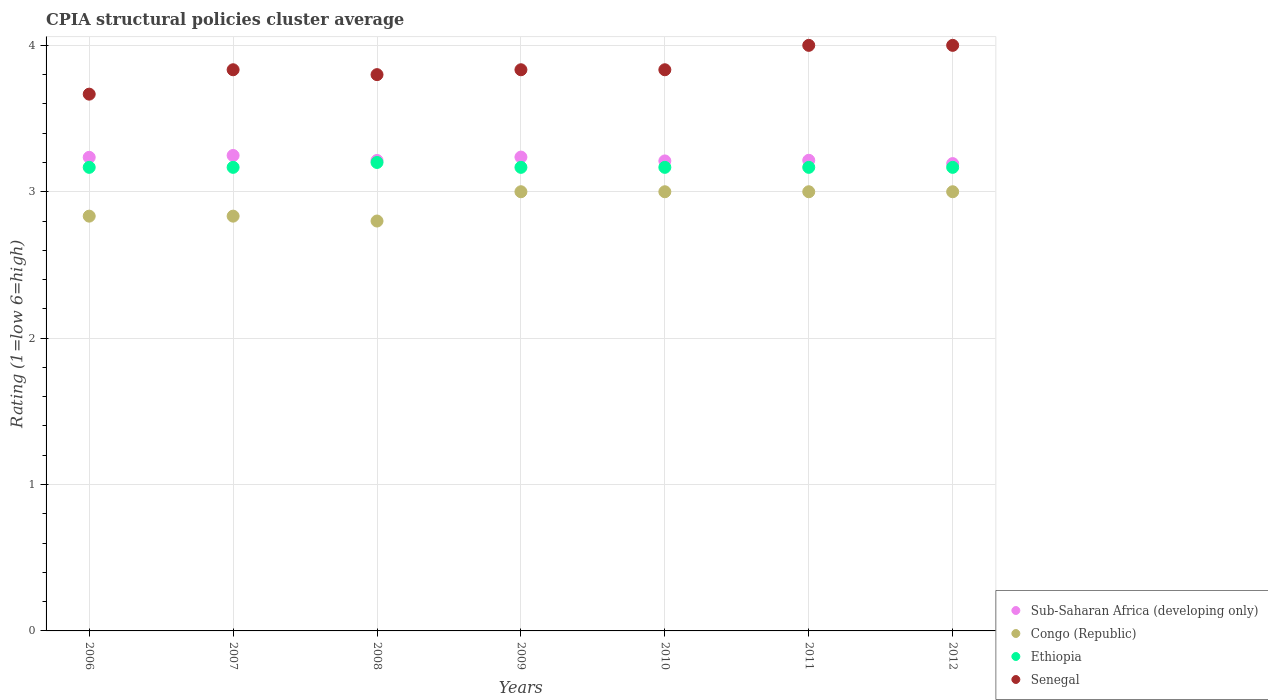Is the number of dotlines equal to the number of legend labels?
Provide a succinct answer. Yes. Across all years, what is the maximum CPIA rating in Ethiopia?
Offer a terse response. 3.2. Across all years, what is the minimum CPIA rating in Congo (Republic)?
Ensure brevity in your answer.  2.8. What is the total CPIA rating in Sub-Saharan Africa (developing only) in the graph?
Your answer should be compact. 22.55. What is the difference between the CPIA rating in Ethiopia in 2008 and that in 2011?
Keep it short and to the point. 0.03. What is the difference between the CPIA rating in Sub-Saharan Africa (developing only) in 2011 and the CPIA rating in Ethiopia in 2007?
Provide a short and direct response. 0.05. What is the average CPIA rating in Senegal per year?
Ensure brevity in your answer.  3.85. In the year 2012, what is the difference between the CPIA rating in Senegal and CPIA rating in Sub-Saharan Africa (developing only)?
Offer a terse response. 0.81. In how many years, is the CPIA rating in Congo (Republic) greater than 2.8?
Give a very brief answer. 6. What is the ratio of the CPIA rating in Ethiopia in 2006 to that in 2008?
Your answer should be compact. 0.99. Is the CPIA rating in Ethiopia in 2007 less than that in 2008?
Make the answer very short. Yes. Is the difference between the CPIA rating in Senegal in 2007 and 2009 greater than the difference between the CPIA rating in Sub-Saharan Africa (developing only) in 2007 and 2009?
Your answer should be compact. No. What is the difference between the highest and the second highest CPIA rating in Senegal?
Your answer should be very brief. 0. What is the difference between the highest and the lowest CPIA rating in Ethiopia?
Your answer should be compact. 0.03. Is the sum of the CPIA rating in Ethiopia in 2006 and 2011 greater than the maximum CPIA rating in Congo (Republic) across all years?
Keep it short and to the point. Yes. Is it the case that in every year, the sum of the CPIA rating in Senegal and CPIA rating in Sub-Saharan Africa (developing only)  is greater than the sum of CPIA rating in Congo (Republic) and CPIA rating in Ethiopia?
Your answer should be very brief. Yes. Is it the case that in every year, the sum of the CPIA rating in Senegal and CPIA rating in Congo (Republic)  is greater than the CPIA rating in Sub-Saharan Africa (developing only)?
Your answer should be very brief. Yes. What is the difference between two consecutive major ticks on the Y-axis?
Your answer should be compact. 1. Are the values on the major ticks of Y-axis written in scientific E-notation?
Provide a short and direct response. No. Does the graph contain any zero values?
Make the answer very short. No. Does the graph contain grids?
Provide a short and direct response. Yes. Where does the legend appear in the graph?
Provide a succinct answer. Bottom right. How are the legend labels stacked?
Your answer should be very brief. Vertical. What is the title of the graph?
Ensure brevity in your answer.  CPIA structural policies cluster average. Does "Algeria" appear as one of the legend labels in the graph?
Your response must be concise. No. What is the Rating (1=low 6=high) of Sub-Saharan Africa (developing only) in 2006?
Offer a terse response. 3.24. What is the Rating (1=low 6=high) of Congo (Republic) in 2006?
Offer a terse response. 2.83. What is the Rating (1=low 6=high) of Ethiopia in 2006?
Make the answer very short. 3.17. What is the Rating (1=low 6=high) in Senegal in 2006?
Ensure brevity in your answer.  3.67. What is the Rating (1=low 6=high) of Sub-Saharan Africa (developing only) in 2007?
Ensure brevity in your answer.  3.25. What is the Rating (1=low 6=high) in Congo (Republic) in 2007?
Provide a short and direct response. 2.83. What is the Rating (1=low 6=high) in Ethiopia in 2007?
Ensure brevity in your answer.  3.17. What is the Rating (1=low 6=high) of Senegal in 2007?
Your answer should be very brief. 3.83. What is the Rating (1=low 6=high) in Sub-Saharan Africa (developing only) in 2008?
Provide a succinct answer. 3.21. What is the Rating (1=low 6=high) of Congo (Republic) in 2008?
Provide a succinct answer. 2.8. What is the Rating (1=low 6=high) of Ethiopia in 2008?
Make the answer very short. 3.2. What is the Rating (1=low 6=high) of Senegal in 2008?
Your response must be concise. 3.8. What is the Rating (1=low 6=high) in Sub-Saharan Africa (developing only) in 2009?
Provide a short and direct response. 3.24. What is the Rating (1=low 6=high) in Ethiopia in 2009?
Give a very brief answer. 3.17. What is the Rating (1=low 6=high) of Senegal in 2009?
Provide a succinct answer. 3.83. What is the Rating (1=low 6=high) in Sub-Saharan Africa (developing only) in 2010?
Provide a short and direct response. 3.21. What is the Rating (1=low 6=high) of Ethiopia in 2010?
Your answer should be very brief. 3.17. What is the Rating (1=low 6=high) of Senegal in 2010?
Your answer should be compact. 3.83. What is the Rating (1=low 6=high) in Sub-Saharan Africa (developing only) in 2011?
Your response must be concise. 3.21. What is the Rating (1=low 6=high) in Congo (Republic) in 2011?
Your response must be concise. 3. What is the Rating (1=low 6=high) of Ethiopia in 2011?
Your response must be concise. 3.17. What is the Rating (1=low 6=high) of Sub-Saharan Africa (developing only) in 2012?
Keep it short and to the point. 3.19. What is the Rating (1=low 6=high) of Ethiopia in 2012?
Offer a terse response. 3.17. Across all years, what is the maximum Rating (1=low 6=high) of Sub-Saharan Africa (developing only)?
Your answer should be very brief. 3.25. Across all years, what is the maximum Rating (1=low 6=high) of Ethiopia?
Give a very brief answer. 3.2. Across all years, what is the maximum Rating (1=low 6=high) in Senegal?
Ensure brevity in your answer.  4. Across all years, what is the minimum Rating (1=low 6=high) of Sub-Saharan Africa (developing only)?
Offer a terse response. 3.19. Across all years, what is the minimum Rating (1=low 6=high) in Ethiopia?
Provide a succinct answer. 3.17. Across all years, what is the minimum Rating (1=low 6=high) of Senegal?
Provide a succinct answer. 3.67. What is the total Rating (1=low 6=high) in Sub-Saharan Africa (developing only) in the graph?
Offer a terse response. 22.55. What is the total Rating (1=low 6=high) of Congo (Republic) in the graph?
Your response must be concise. 20.47. What is the total Rating (1=low 6=high) in Senegal in the graph?
Offer a very short reply. 26.97. What is the difference between the Rating (1=low 6=high) of Sub-Saharan Africa (developing only) in 2006 and that in 2007?
Keep it short and to the point. -0.01. What is the difference between the Rating (1=low 6=high) of Congo (Republic) in 2006 and that in 2007?
Provide a short and direct response. 0. What is the difference between the Rating (1=low 6=high) of Ethiopia in 2006 and that in 2007?
Your response must be concise. 0. What is the difference between the Rating (1=low 6=high) of Senegal in 2006 and that in 2007?
Ensure brevity in your answer.  -0.17. What is the difference between the Rating (1=low 6=high) of Sub-Saharan Africa (developing only) in 2006 and that in 2008?
Provide a succinct answer. 0.02. What is the difference between the Rating (1=low 6=high) in Ethiopia in 2006 and that in 2008?
Your answer should be very brief. -0.03. What is the difference between the Rating (1=low 6=high) in Senegal in 2006 and that in 2008?
Your answer should be very brief. -0.13. What is the difference between the Rating (1=low 6=high) of Sub-Saharan Africa (developing only) in 2006 and that in 2009?
Provide a succinct answer. -0. What is the difference between the Rating (1=low 6=high) in Congo (Republic) in 2006 and that in 2009?
Provide a succinct answer. -0.17. What is the difference between the Rating (1=low 6=high) in Sub-Saharan Africa (developing only) in 2006 and that in 2010?
Your response must be concise. 0.02. What is the difference between the Rating (1=low 6=high) of Ethiopia in 2006 and that in 2010?
Your answer should be very brief. 0. What is the difference between the Rating (1=low 6=high) of Senegal in 2006 and that in 2010?
Your answer should be very brief. -0.17. What is the difference between the Rating (1=low 6=high) in Sub-Saharan Africa (developing only) in 2006 and that in 2011?
Provide a succinct answer. 0.02. What is the difference between the Rating (1=low 6=high) of Ethiopia in 2006 and that in 2011?
Make the answer very short. 0. What is the difference between the Rating (1=low 6=high) of Sub-Saharan Africa (developing only) in 2006 and that in 2012?
Your answer should be very brief. 0.04. What is the difference between the Rating (1=low 6=high) in Ethiopia in 2006 and that in 2012?
Give a very brief answer. 0. What is the difference between the Rating (1=low 6=high) in Senegal in 2006 and that in 2012?
Offer a terse response. -0.33. What is the difference between the Rating (1=low 6=high) in Sub-Saharan Africa (developing only) in 2007 and that in 2008?
Keep it short and to the point. 0.03. What is the difference between the Rating (1=low 6=high) in Ethiopia in 2007 and that in 2008?
Keep it short and to the point. -0.03. What is the difference between the Rating (1=low 6=high) in Sub-Saharan Africa (developing only) in 2007 and that in 2009?
Provide a short and direct response. 0.01. What is the difference between the Rating (1=low 6=high) in Congo (Republic) in 2007 and that in 2009?
Give a very brief answer. -0.17. What is the difference between the Rating (1=low 6=high) of Sub-Saharan Africa (developing only) in 2007 and that in 2010?
Provide a short and direct response. 0.04. What is the difference between the Rating (1=low 6=high) in Congo (Republic) in 2007 and that in 2010?
Keep it short and to the point. -0.17. What is the difference between the Rating (1=low 6=high) in Sub-Saharan Africa (developing only) in 2007 and that in 2011?
Your answer should be very brief. 0.03. What is the difference between the Rating (1=low 6=high) in Ethiopia in 2007 and that in 2011?
Your response must be concise. 0. What is the difference between the Rating (1=low 6=high) in Senegal in 2007 and that in 2011?
Your response must be concise. -0.17. What is the difference between the Rating (1=low 6=high) of Sub-Saharan Africa (developing only) in 2007 and that in 2012?
Your answer should be compact. 0.06. What is the difference between the Rating (1=low 6=high) in Ethiopia in 2007 and that in 2012?
Your answer should be compact. 0. What is the difference between the Rating (1=low 6=high) in Sub-Saharan Africa (developing only) in 2008 and that in 2009?
Offer a terse response. -0.02. What is the difference between the Rating (1=low 6=high) in Congo (Republic) in 2008 and that in 2009?
Make the answer very short. -0.2. What is the difference between the Rating (1=low 6=high) of Senegal in 2008 and that in 2009?
Provide a succinct answer. -0.03. What is the difference between the Rating (1=low 6=high) of Sub-Saharan Africa (developing only) in 2008 and that in 2010?
Offer a terse response. 0. What is the difference between the Rating (1=low 6=high) of Ethiopia in 2008 and that in 2010?
Your response must be concise. 0.03. What is the difference between the Rating (1=low 6=high) in Senegal in 2008 and that in 2010?
Offer a terse response. -0.03. What is the difference between the Rating (1=low 6=high) in Sub-Saharan Africa (developing only) in 2008 and that in 2011?
Offer a terse response. -0. What is the difference between the Rating (1=low 6=high) of Congo (Republic) in 2008 and that in 2011?
Provide a succinct answer. -0.2. What is the difference between the Rating (1=low 6=high) in Ethiopia in 2008 and that in 2011?
Keep it short and to the point. 0.03. What is the difference between the Rating (1=low 6=high) in Sub-Saharan Africa (developing only) in 2008 and that in 2012?
Ensure brevity in your answer.  0.02. What is the difference between the Rating (1=low 6=high) of Sub-Saharan Africa (developing only) in 2009 and that in 2010?
Offer a terse response. 0.03. What is the difference between the Rating (1=low 6=high) of Ethiopia in 2009 and that in 2010?
Your answer should be compact. 0. What is the difference between the Rating (1=low 6=high) of Sub-Saharan Africa (developing only) in 2009 and that in 2011?
Make the answer very short. 0.02. What is the difference between the Rating (1=low 6=high) in Ethiopia in 2009 and that in 2011?
Your response must be concise. 0. What is the difference between the Rating (1=low 6=high) in Sub-Saharan Africa (developing only) in 2009 and that in 2012?
Offer a very short reply. 0.04. What is the difference between the Rating (1=low 6=high) of Congo (Republic) in 2009 and that in 2012?
Give a very brief answer. 0. What is the difference between the Rating (1=low 6=high) in Senegal in 2009 and that in 2012?
Provide a short and direct response. -0.17. What is the difference between the Rating (1=low 6=high) of Sub-Saharan Africa (developing only) in 2010 and that in 2011?
Ensure brevity in your answer.  -0. What is the difference between the Rating (1=low 6=high) of Ethiopia in 2010 and that in 2011?
Provide a succinct answer. 0. What is the difference between the Rating (1=low 6=high) of Sub-Saharan Africa (developing only) in 2010 and that in 2012?
Your answer should be compact. 0.02. What is the difference between the Rating (1=low 6=high) in Ethiopia in 2010 and that in 2012?
Offer a terse response. 0. What is the difference between the Rating (1=low 6=high) in Senegal in 2010 and that in 2012?
Offer a very short reply. -0.17. What is the difference between the Rating (1=low 6=high) in Sub-Saharan Africa (developing only) in 2011 and that in 2012?
Offer a very short reply. 0.02. What is the difference between the Rating (1=low 6=high) of Congo (Republic) in 2011 and that in 2012?
Your answer should be compact. 0. What is the difference between the Rating (1=low 6=high) of Ethiopia in 2011 and that in 2012?
Give a very brief answer. 0. What is the difference between the Rating (1=low 6=high) in Senegal in 2011 and that in 2012?
Give a very brief answer. 0. What is the difference between the Rating (1=low 6=high) in Sub-Saharan Africa (developing only) in 2006 and the Rating (1=low 6=high) in Congo (Republic) in 2007?
Give a very brief answer. 0.4. What is the difference between the Rating (1=low 6=high) of Sub-Saharan Africa (developing only) in 2006 and the Rating (1=low 6=high) of Ethiopia in 2007?
Your response must be concise. 0.07. What is the difference between the Rating (1=low 6=high) of Sub-Saharan Africa (developing only) in 2006 and the Rating (1=low 6=high) of Senegal in 2007?
Give a very brief answer. -0.6. What is the difference between the Rating (1=low 6=high) in Sub-Saharan Africa (developing only) in 2006 and the Rating (1=low 6=high) in Congo (Republic) in 2008?
Keep it short and to the point. 0.44. What is the difference between the Rating (1=low 6=high) of Sub-Saharan Africa (developing only) in 2006 and the Rating (1=low 6=high) of Ethiopia in 2008?
Your answer should be very brief. 0.04. What is the difference between the Rating (1=low 6=high) in Sub-Saharan Africa (developing only) in 2006 and the Rating (1=low 6=high) in Senegal in 2008?
Offer a terse response. -0.56. What is the difference between the Rating (1=low 6=high) of Congo (Republic) in 2006 and the Rating (1=low 6=high) of Ethiopia in 2008?
Keep it short and to the point. -0.37. What is the difference between the Rating (1=low 6=high) of Congo (Republic) in 2006 and the Rating (1=low 6=high) of Senegal in 2008?
Keep it short and to the point. -0.97. What is the difference between the Rating (1=low 6=high) in Ethiopia in 2006 and the Rating (1=low 6=high) in Senegal in 2008?
Your response must be concise. -0.63. What is the difference between the Rating (1=low 6=high) in Sub-Saharan Africa (developing only) in 2006 and the Rating (1=low 6=high) in Congo (Republic) in 2009?
Your answer should be very brief. 0.24. What is the difference between the Rating (1=low 6=high) in Sub-Saharan Africa (developing only) in 2006 and the Rating (1=low 6=high) in Ethiopia in 2009?
Give a very brief answer. 0.07. What is the difference between the Rating (1=low 6=high) in Sub-Saharan Africa (developing only) in 2006 and the Rating (1=low 6=high) in Senegal in 2009?
Provide a succinct answer. -0.6. What is the difference between the Rating (1=low 6=high) of Congo (Republic) in 2006 and the Rating (1=low 6=high) of Ethiopia in 2009?
Keep it short and to the point. -0.33. What is the difference between the Rating (1=low 6=high) in Sub-Saharan Africa (developing only) in 2006 and the Rating (1=low 6=high) in Congo (Republic) in 2010?
Keep it short and to the point. 0.24. What is the difference between the Rating (1=low 6=high) in Sub-Saharan Africa (developing only) in 2006 and the Rating (1=low 6=high) in Ethiopia in 2010?
Give a very brief answer. 0.07. What is the difference between the Rating (1=low 6=high) in Sub-Saharan Africa (developing only) in 2006 and the Rating (1=low 6=high) in Senegal in 2010?
Your answer should be very brief. -0.6. What is the difference between the Rating (1=low 6=high) of Congo (Republic) in 2006 and the Rating (1=low 6=high) of Ethiopia in 2010?
Your answer should be very brief. -0.33. What is the difference between the Rating (1=low 6=high) of Congo (Republic) in 2006 and the Rating (1=low 6=high) of Senegal in 2010?
Your answer should be compact. -1. What is the difference between the Rating (1=low 6=high) of Ethiopia in 2006 and the Rating (1=low 6=high) of Senegal in 2010?
Give a very brief answer. -0.67. What is the difference between the Rating (1=low 6=high) in Sub-Saharan Africa (developing only) in 2006 and the Rating (1=low 6=high) in Congo (Republic) in 2011?
Provide a short and direct response. 0.24. What is the difference between the Rating (1=low 6=high) in Sub-Saharan Africa (developing only) in 2006 and the Rating (1=low 6=high) in Ethiopia in 2011?
Offer a terse response. 0.07. What is the difference between the Rating (1=low 6=high) in Sub-Saharan Africa (developing only) in 2006 and the Rating (1=low 6=high) in Senegal in 2011?
Your answer should be compact. -0.76. What is the difference between the Rating (1=low 6=high) of Congo (Republic) in 2006 and the Rating (1=low 6=high) of Senegal in 2011?
Provide a succinct answer. -1.17. What is the difference between the Rating (1=low 6=high) in Ethiopia in 2006 and the Rating (1=low 6=high) in Senegal in 2011?
Your answer should be very brief. -0.83. What is the difference between the Rating (1=low 6=high) in Sub-Saharan Africa (developing only) in 2006 and the Rating (1=low 6=high) in Congo (Republic) in 2012?
Your answer should be compact. 0.24. What is the difference between the Rating (1=low 6=high) in Sub-Saharan Africa (developing only) in 2006 and the Rating (1=low 6=high) in Ethiopia in 2012?
Give a very brief answer. 0.07. What is the difference between the Rating (1=low 6=high) in Sub-Saharan Africa (developing only) in 2006 and the Rating (1=low 6=high) in Senegal in 2012?
Your response must be concise. -0.76. What is the difference between the Rating (1=low 6=high) in Congo (Republic) in 2006 and the Rating (1=low 6=high) in Senegal in 2012?
Your response must be concise. -1.17. What is the difference between the Rating (1=low 6=high) in Sub-Saharan Africa (developing only) in 2007 and the Rating (1=low 6=high) in Congo (Republic) in 2008?
Your answer should be compact. 0.45. What is the difference between the Rating (1=low 6=high) of Sub-Saharan Africa (developing only) in 2007 and the Rating (1=low 6=high) of Ethiopia in 2008?
Offer a very short reply. 0.05. What is the difference between the Rating (1=low 6=high) of Sub-Saharan Africa (developing only) in 2007 and the Rating (1=low 6=high) of Senegal in 2008?
Provide a short and direct response. -0.55. What is the difference between the Rating (1=low 6=high) in Congo (Republic) in 2007 and the Rating (1=low 6=high) in Ethiopia in 2008?
Your answer should be compact. -0.37. What is the difference between the Rating (1=low 6=high) in Congo (Republic) in 2007 and the Rating (1=low 6=high) in Senegal in 2008?
Make the answer very short. -0.97. What is the difference between the Rating (1=low 6=high) in Ethiopia in 2007 and the Rating (1=low 6=high) in Senegal in 2008?
Offer a terse response. -0.63. What is the difference between the Rating (1=low 6=high) in Sub-Saharan Africa (developing only) in 2007 and the Rating (1=low 6=high) in Congo (Republic) in 2009?
Provide a short and direct response. 0.25. What is the difference between the Rating (1=low 6=high) in Sub-Saharan Africa (developing only) in 2007 and the Rating (1=low 6=high) in Ethiopia in 2009?
Your response must be concise. 0.08. What is the difference between the Rating (1=low 6=high) in Sub-Saharan Africa (developing only) in 2007 and the Rating (1=low 6=high) in Senegal in 2009?
Your answer should be compact. -0.59. What is the difference between the Rating (1=low 6=high) in Congo (Republic) in 2007 and the Rating (1=low 6=high) in Senegal in 2009?
Your answer should be compact. -1. What is the difference between the Rating (1=low 6=high) of Ethiopia in 2007 and the Rating (1=low 6=high) of Senegal in 2009?
Ensure brevity in your answer.  -0.67. What is the difference between the Rating (1=low 6=high) in Sub-Saharan Africa (developing only) in 2007 and the Rating (1=low 6=high) in Congo (Republic) in 2010?
Give a very brief answer. 0.25. What is the difference between the Rating (1=low 6=high) of Sub-Saharan Africa (developing only) in 2007 and the Rating (1=low 6=high) of Ethiopia in 2010?
Your answer should be compact. 0.08. What is the difference between the Rating (1=low 6=high) of Sub-Saharan Africa (developing only) in 2007 and the Rating (1=low 6=high) of Senegal in 2010?
Provide a short and direct response. -0.59. What is the difference between the Rating (1=low 6=high) of Congo (Republic) in 2007 and the Rating (1=low 6=high) of Senegal in 2010?
Give a very brief answer. -1. What is the difference between the Rating (1=low 6=high) in Ethiopia in 2007 and the Rating (1=low 6=high) in Senegal in 2010?
Your answer should be very brief. -0.67. What is the difference between the Rating (1=low 6=high) in Sub-Saharan Africa (developing only) in 2007 and the Rating (1=low 6=high) in Congo (Republic) in 2011?
Provide a succinct answer. 0.25. What is the difference between the Rating (1=low 6=high) of Sub-Saharan Africa (developing only) in 2007 and the Rating (1=low 6=high) of Ethiopia in 2011?
Give a very brief answer. 0.08. What is the difference between the Rating (1=low 6=high) of Sub-Saharan Africa (developing only) in 2007 and the Rating (1=low 6=high) of Senegal in 2011?
Make the answer very short. -0.75. What is the difference between the Rating (1=low 6=high) in Congo (Republic) in 2007 and the Rating (1=low 6=high) in Senegal in 2011?
Make the answer very short. -1.17. What is the difference between the Rating (1=low 6=high) in Sub-Saharan Africa (developing only) in 2007 and the Rating (1=low 6=high) in Congo (Republic) in 2012?
Offer a terse response. 0.25. What is the difference between the Rating (1=low 6=high) in Sub-Saharan Africa (developing only) in 2007 and the Rating (1=low 6=high) in Ethiopia in 2012?
Your answer should be compact. 0.08. What is the difference between the Rating (1=low 6=high) in Sub-Saharan Africa (developing only) in 2007 and the Rating (1=low 6=high) in Senegal in 2012?
Offer a very short reply. -0.75. What is the difference between the Rating (1=low 6=high) of Congo (Republic) in 2007 and the Rating (1=low 6=high) of Ethiopia in 2012?
Keep it short and to the point. -0.33. What is the difference between the Rating (1=low 6=high) in Congo (Republic) in 2007 and the Rating (1=low 6=high) in Senegal in 2012?
Keep it short and to the point. -1.17. What is the difference between the Rating (1=low 6=high) in Ethiopia in 2007 and the Rating (1=low 6=high) in Senegal in 2012?
Provide a short and direct response. -0.83. What is the difference between the Rating (1=low 6=high) of Sub-Saharan Africa (developing only) in 2008 and the Rating (1=low 6=high) of Congo (Republic) in 2009?
Your response must be concise. 0.21. What is the difference between the Rating (1=low 6=high) in Sub-Saharan Africa (developing only) in 2008 and the Rating (1=low 6=high) in Ethiopia in 2009?
Your answer should be very brief. 0.05. What is the difference between the Rating (1=low 6=high) of Sub-Saharan Africa (developing only) in 2008 and the Rating (1=low 6=high) of Senegal in 2009?
Provide a succinct answer. -0.62. What is the difference between the Rating (1=low 6=high) in Congo (Republic) in 2008 and the Rating (1=low 6=high) in Ethiopia in 2009?
Offer a very short reply. -0.37. What is the difference between the Rating (1=low 6=high) of Congo (Republic) in 2008 and the Rating (1=low 6=high) of Senegal in 2009?
Provide a short and direct response. -1.03. What is the difference between the Rating (1=low 6=high) in Ethiopia in 2008 and the Rating (1=low 6=high) in Senegal in 2009?
Give a very brief answer. -0.63. What is the difference between the Rating (1=low 6=high) in Sub-Saharan Africa (developing only) in 2008 and the Rating (1=low 6=high) in Congo (Republic) in 2010?
Your answer should be very brief. 0.21. What is the difference between the Rating (1=low 6=high) of Sub-Saharan Africa (developing only) in 2008 and the Rating (1=low 6=high) of Ethiopia in 2010?
Provide a short and direct response. 0.05. What is the difference between the Rating (1=low 6=high) in Sub-Saharan Africa (developing only) in 2008 and the Rating (1=low 6=high) in Senegal in 2010?
Offer a terse response. -0.62. What is the difference between the Rating (1=low 6=high) of Congo (Republic) in 2008 and the Rating (1=low 6=high) of Ethiopia in 2010?
Your response must be concise. -0.37. What is the difference between the Rating (1=low 6=high) in Congo (Republic) in 2008 and the Rating (1=low 6=high) in Senegal in 2010?
Your response must be concise. -1.03. What is the difference between the Rating (1=low 6=high) in Ethiopia in 2008 and the Rating (1=low 6=high) in Senegal in 2010?
Your response must be concise. -0.63. What is the difference between the Rating (1=low 6=high) in Sub-Saharan Africa (developing only) in 2008 and the Rating (1=low 6=high) in Congo (Republic) in 2011?
Ensure brevity in your answer.  0.21. What is the difference between the Rating (1=low 6=high) of Sub-Saharan Africa (developing only) in 2008 and the Rating (1=low 6=high) of Ethiopia in 2011?
Your response must be concise. 0.05. What is the difference between the Rating (1=low 6=high) in Sub-Saharan Africa (developing only) in 2008 and the Rating (1=low 6=high) in Senegal in 2011?
Ensure brevity in your answer.  -0.79. What is the difference between the Rating (1=low 6=high) in Congo (Republic) in 2008 and the Rating (1=low 6=high) in Ethiopia in 2011?
Your answer should be very brief. -0.37. What is the difference between the Rating (1=low 6=high) of Ethiopia in 2008 and the Rating (1=low 6=high) of Senegal in 2011?
Offer a very short reply. -0.8. What is the difference between the Rating (1=low 6=high) of Sub-Saharan Africa (developing only) in 2008 and the Rating (1=low 6=high) of Congo (Republic) in 2012?
Offer a terse response. 0.21. What is the difference between the Rating (1=low 6=high) of Sub-Saharan Africa (developing only) in 2008 and the Rating (1=low 6=high) of Ethiopia in 2012?
Give a very brief answer. 0.05. What is the difference between the Rating (1=low 6=high) of Sub-Saharan Africa (developing only) in 2008 and the Rating (1=low 6=high) of Senegal in 2012?
Keep it short and to the point. -0.79. What is the difference between the Rating (1=low 6=high) in Congo (Republic) in 2008 and the Rating (1=low 6=high) in Ethiopia in 2012?
Your answer should be compact. -0.37. What is the difference between the Rating (1=low 6=high) of Congo (Republic) in 2008 and the Rating (1=low 6=high) of Senegal in 2012?
Keep it short and to the point. -1.2. What is the difference between the Rating (1=low 6=high) of Ethiopia in 2008 and the Rating (1=low 6=high) of Senegal in 2012?
Keep it short and to the point. -0.8. What is the difference between the Rating (1=low 6=high) of Sub-Saharan Africa (developing only) in 2009 and the Rating (1=low 6=high) of Congo (Republic) in 2010?
Offer a very short reply. 0.24. What is the difference between the Rating (1=low 6=high) of Sub-Saharan Africa (developing only) in 2009 and the Rating (1=low 6=high) of Ethiopia in 2010?
Provide a succinct answer. 0.07. What is the difference between the Rating (1=low 6=high) in Sub-Saharan Africa (developing only) in 2009 and the Rating (1=low 6=high) in Senegal in 2010?
Keep it short and to the point. -0.6. What is the difference between the Rating (1=low 6=high) in Congo (Republic) in 2009 and the Rating (1=low 6=high) in Ethiopia in 2010?
Provide a succinct answer. -0.17. What is the difference between the Rating (1=low 6=high) of Sub-Saharan Africa (developing only) in 2009 and the Rating (1=low 6=high) of Congo (Republic) in 2011?
Offer a very short reply. 0.24. What is the difference between the Rating (1=low 6=high) in Sub-Saharan Africa (developing only) in 2009 and the Rating (1=low 6=high) in Ethiopia in 2011?
Keep it short and to the point. 0.07. What is the difference between the Rating (1=low 6=high) in Sub-Saharan Africa (developing only) in 2009 and the Rating (1=low 6=high) in Senegal in 2011?
Offer a very short reply. -0.76. What is the difference between the Rating (1=low 6=high) of Congo (Republic) in 2009 and the Rating (1=low 6=high) of Ethiopia in 2011?
Your response must be concise. -0.17. What is the difference between the Rating (1=low 6=high) in Ethiopia in 2009 and the Rating (1=low 6=high) in Senegal in 2011?
Offer a terse response. -0.83. What is the difference between the Rating (1=low 6=high) in Sub-Saharan Africa (developing only) in 2009 and the Rating (1=low 6=high) in Congo (Republic) in 2012?
Provide a succinct answer. 0.24. What is the difference between the Rating (1=low 6=high) in Sub-Saharan Africa (developing only) in 2009 and the Rating (1=low 6=high) in Ethiopia in 2012?
Offer a terse response. 0.07. What is the difference between the Rating (1=low 6=high) in Sub-Saharan Africa (developing only) in 2009 and the Rating (1=low 6=high) in Senegal in 2012?
Ensure brevity in your answer.  -0.76. What is the difference between the Rating (1=low 6=high) in Ethiopia in 2009 and the Rating (1=low 6=high) in Senegal in 2012?
Ensure brevity in your answer.  -0.83. What is the difference between the Rating (1=low 6=high) in Sub-Saharan Africa (developing only) in 2010 and the Rating (1=low 6=high) in Congo (Republic) in 2011?
Keep it short and to the point. 0.21. What is the difference between the Rating (1=low 6=high) of Sub-Saharan Africa (developing only) in 2010 and the Rating (1=low 6=high) of Ethiopia in 2011?
Keep it short and to the point. 0.04. What is the difference between the Rating (1=low 6=high) in Sub-Saharan Africa (developing only) in 2010 and the Rating (1=low 6=high) in Senegal in 2011?
Make the answer very short. -0.79. What is the difference between the Rating (1=low 6=high) in Congo (Republic) in 2010 and the Rating (1=low 6=high) in Ethiopia in 2011?
Provide a succinct answer. -0.17. What is the difference between the Rating (1=low 6=high) of Congo (Republic) in 2010 and the Rating (1=low 6=high) of Senegal in 2011?
Your answer should be compact. -1. What is the difference between the Rating (1=low 6=high) of Sub-Saharan Africa (developing only) in 2010 and the Rating (1=low 6=high) of Congo (Republic) in 2012?
Your answer should be very brief. 0.21. What is the difference between the Rating (1=low 6=high) of Sub-Saharan Africa (developing only) in 2010 and the Rating (1=low 6=high) of Ethiopia in 2012?
Offer a terse response. 0.04. What is the difference between the Rating (1=low 6=high) in Sub-Saharan Africa (developing only) in 2010 and the Rating (1=low 6=high) in Senegal in 2012?
Your answer should be very brief. -0.79. What is the difference between the Rating (1=low 6=high) in Congo (Republic) in 2010 and the Rating (1=low 6=high) in Ethiopia in 2012?
Ensure brevity in your answer.  -0.17. What is the difference between the Rating (1=low 6=high) in Ethiopia in 2010 and the Rating (1=low 6=high) in Senegal in 2012?
Your response must be concise. -0.83. What is the difference between the Rating (1=low 6=high) in Sub-Saharan Africa (developing only) in 2011 and the Rating (1=low 6=high) in Congo (Republic) in 2012?
Ensure brevity in your answer.  0.21. What is the difference between the Rating (1=low 6=high) of Sub-Saharan Africa (developing only) in 2011 and the Rating (1=low 6=high) of Ethiopia in 2012?
Your answer should be very brief. 0.05. What is the difference between the Rating (1=low 6=high) of Sub-Saharan Africa (developing only) in 2011 and the Rating (1=low 6=high) of Senegal in 2012?
Your answer should be very brief. -0.79. What is the difference between the Rating (1=low 6=high) in Ethiopia in 2011 and the Rating (1=low 6=high) in Senegal in 2012?
Ensure brevity in your answer.  -0.83. What is the average Rating (1=low 6=high) of Sub-Saharan Africa (developing only) per year?
Your answer should be very brief. 3.22. What is the average Rating (1=low 6=high) in Congo (Republic) per year?
Provide a succinct answer. 2.92. What is the average Rating (1=low 6=high) of Ethiopia per year?
Your answer should be compact. 3.17. What is the average Rating (1=low 6=high) in Senegal per year?
Your answer should be compact. 3.85. In the year 2006, what is the difference between the Rating (1=low 6=high) in Sub-Saharan Africa (developing only) and Rating (1=low 6=high) in Congo (Republic)?
Provide a succinct answer. 0.4. In the year 2006, what is the difference between the Rating (1=low 6=high) of Sub-Saharan Africa (developing only) and Rating (1=low 6=high) of Ethiopia?
Your answer should be very brief. 0.07. In the year 2006, what is the difference between the Rating (1=low 6=high) of Sub-Saharan Africa (developing only) and Rating (1=low 6=high) of Senegal?
Make the answer very short. -0.43. In the year 2006, what is the difference between the Rating (1=low 6=high) in Congo (Republic) and Rating (1=low 6=high) in Ethiopia?
Your answer should be compact. -0.33. In the year 2007, what is the difference between the Rating (1=low 6=high) of Sub-Saharan Africa (developing only) and Rating (1=low 6=high) of Congo (Republic)?
Provide a succinct answer. 0.41. In the year 2007, what is the difference between the Rating (1=low 6=high) in Sub-Saharan Africa (developing only) and Rating (1=low 6=high) in Ethiopia?
Give a very brief answer. 0.08. In the year 2007, what is the difference between the Rating (1=low 6=high) of Sub-Saharan Africa (developing only) and Rating (1=low 6=high) of Senegal?
Provide a succinct answer. -0.59. In the year 2007, what is the difference between the Rating (1=low 6=high) of Congo (Republic) and Rating (1=low 6=high) of Ethiopia?
Make the answer very short. -0.33. In the year 2007, what is the difference between the Rating (1=low 6=high) in Congo (Republic) and Rating (1=low 6=high) in Senegal?
Your answer should be compact. -1. In the year 2007, what is the difference between the Rating (1=low 6=high) in Ethiopia and Rating (1=low 6=high) in Senegal?
Make the answer very short. -0.67. In the year 2008, what is the difference between the Rating (1=low 6=high) in Sub-Saharan Africa (developing only) and Rating (1=low 6=high) in Congo (Republic)?
Provide a short and direct response. 0.41. In the year 2008, what is the difference between the Rating (1=low 6=high) in Sub-Saharan Africa (developing only) and Rating (1=low 6=high) in Ethiopia?
Offer a very short reply. 0.01. In the year 2008, what is the difference between the Rating (1=low 6=high) of Sub-Saharan Africa (developing only) and Rating (1=low 6=high) of Senegal?
Keep it short and to the point. -0.59. In the year 2008, what is the difference between the Rating (1=low 6=high) in Congo (Republic) and Rating (1=low 6=high) in Senegal?
Your response must be concise. -1. In the year 2009, what is the difference between the Rating (1=low 6=high) in Sub-Saharan Africa (developing only) and Rating (1=low 6=high) in Congo (Republic)?
Offer a very short reply. 0.24. In the year 2009, what is the difference between the Rating (1=low 6=high) in Sub-Saharan Africa (developing only) and Rating (1=low 6=high) in Ethiopia?
Your response must be concise. 0.07. In the year 2009, what is the difference between the Rating (1=low 6=high) in Sub-Saharan Africa (developing only) and Rating (1=low 6=high) in Senegal?
Ensure brevity in your answer.  -0.6. In the year 2010, what is the difference between the Rating (1=low 6=high) of Sub-Saharan Africa (developing only) and Rating (1=low 6=high) of Congo (Republic)?
Keep it short and to the point. 0.21. In the year 2010, what is the difference between the Rating (1=low 6=high) in Sub-Saharan Africa (developing only) and Rating (1=low 6=high) in Ethiopia?
Offer a terse response. 0.04. In the year 2010, what is the difference between the Rating (1=low 6=high) of Sub-Saharan Africa (developing only) and Rating (1=low 6=high) of Senegal?
Offer a very short reply. -0.62. In the year 2010, what is the difference between the Rating (1=low 6=high) of Congo (Republic) and Rating (1=low 6=high) of Ethiopia?
Ensure brevity in your answer.  -0.17. In the year 2010, what is the difference between the Rating (1=low 6=high) of Ethiopia and Rating (1=low 6=high) of Senegal?
Give a very brief answer. -0.67. In the year 2011, what is the difference between the Rating (1=low 6=high) in Sub-Saharan Africa (developing only) and Rating (1=low 6=high) in Congo (Republic)?
Make the answer very short. 0.21. In the year 2011, what is the difference between the Rating (1=low 6=high) in Sub-Saharan Africa (developing only) and Rating (1=low 6=high) in Ethiopia?
Give a very brief answer. 0.05. In the year 2011, what is the difference between the Rating (1=low 6=high) of Sub-Saharan Africa (developing only) and Rating (1=low 6=high) of Senegal?
Provide a short and direct response. -0.79. In the year 2012, what is the difference between the Rating (1=low 6=high) of Sub-Saharan Africa (developing only) and Rating (1=low 6=high) of Congo (Republic)?
Make the answer very short. 0.19. In the year 2012, what is the difference between the Rating (1=low 6=high) of Sub-Saharan Africa (developing only) and Rating (1=low 6=high) of Ethiopia?
Make the answer very short. 0.03. In the year 2012, what is the difference between the Rating (1=low 6=high) of Sub-Saharan Africa (developing only) and Rating (1=low 6=high) of Senegal?
Your answer should be very brief. -0.81. In the year 2012, what is the difference between the Rating (1=low 6=high) in Congo (Republic) and Rating (1=low 6=high) in Ethiopia?
Offer a terse response. -0.17. What is the ratio of the Rating (1=low 6=high) in Congo (Republic) in 2006 to that in 2007?
Give a very brief answer. 1. What is the ratio of the Rating (1=low 6=high) in Senegal in 2006 to that in 2007?
Your answer should be compact. 0.96. What is the ratio of the Rating (1=low 6=high) in Congo (Republic) in 2006 to that in 2008?
Provide a short and direct response. 1.01. What is the ratio of the Rating (1=low 6=high) in Ethiopia in 2006 to that in 2008?
Give a very brief answer. 0.99. What is the ratio of the Rating (1=low 6=high) in Senegal in 2006 to that in 2008?
Make the answer very short. 0.96. What is the ratio of the Rating (1=low 6=high) of Sub-Saharan Africa (developing only) in 2006 to that in 2009?
Offer a terse response. 1. What is the ratio of the Rating (1=low 6=high) in Congo (Republic) in 2006 to that in 2009?
Offer a very short reply. 0.94. What is the ratio of the Rating (1=low 6=high) of Senegal in 2006 to that in 2009?
Your answer should be compact. 0.96. What is the ratio of the Rating (1=low 6=high) in Sub-Saharan Africa (developing only) in 2006 to that in 2010?
Your answer should be compact. 1.01. What is the ratio of the Rating (1=low 6=high) of Senegal in 2006 to that in 2010?
Keep it short and to the point. 0.96. What is the ratio of the Rating (1=low 6=high) in Sub-Saharan Africa (developing only) in 2006 to that in 2011?
Your response must be concise. 1.01. What is the ratio of the Rating (1=low 6=high) of Congo (Republic) in 2006 to that in 2011?
Your answer should be very brief. 0.94. What is the ratio of the Rating (1=low 6=high) in Sub-Saharan Africa (developing only) in 2006 to that in 2012?
Ensure brevity in your answer.  1.01. What is the ratio of the Rating (1=low 6=high) of Congo (Republic) in 2006 to that in 2012?
Keep it short and to the point. 0.94. What is the ratio of the Rating (1=low 6=high) in Sub-Saharan Africa (developing only) in 2007 to that in 2008?
Provide a short and direct response. 1.01. What is the ratio of the Rating (1=low 6=high) in Congo (Republic) in 2007 to that in 2008?
Offer a very short reply. 1.01. What is the ratio of the Rating (1=low 6=high) in Ethiopia in 2007 to that in 2008?
Offer a terse response. 0.99. What is the ratio of the Rating (1=low 6=high) in Senegal in 2007 to that in 2008?
Give a very brief answer. 1.01. What is the ratio of the Rating (1=low 6=high) in Congo (Republic) in 2007 to that in 2009?
Provide a succinct answer. 0.94. What is the ratio of the Rating (1=low 6=high) of Sub-Saharan Africa (developing only) in 2007 to that in 2010?
Your answer should be compact. 1.01. What is the ratio of the Rating (1=low 6=high) in Sub-Saharan Africa (developing only) in 2007 to that in 2011?
Keep it short and to the point. 1.01. What is the ratio of the Rating (1=low 6=high) of Senegal in 2007 to that in 2011?
Provide a short and direct response. 0.96. What is the ratio of the Rating (1=low 6=high) of Sub-Saharan Africa (developing only) in 2007 to that in 2012?
Provide a succinct answer. 1.02. What is the ratio of the Rating (1=low 6=high) in Ethiopia in 2007 to that in 2012?
Your answer should be very brief. 1. What is the ratio of the Rating (1=low 6=high) of Ethiopia in 2008 to that in 2009?
Your answer should be compact. 1.01. What is the ratio of the Rating (1=low 6=high) of Ethiopia in 2008 to that in 2010?
Ensure brevity in your answer.  1.01. What is the ratio of the Rating (1=low 6=high) in Congo (Republic) in 2008 to that in 2011?
Give a very brief answer. 0.93. What is the ratio of the Rating (1=low 6=high) of Ethiopia in 2008 to that in 2011?
Your answer should be compact. 1.01. What is the ratio of the Rating (1=low 6=high) of Senegal in 2008 to that in 2011?
Keep it short and to the point. 0.95. What is the ratio of the Rating (1=low 6=high) in Sub-Saharan Africa (developing only) in 2008 to that in 2012?
Offer a very short reply. 1.01. What is the ratio of the Rating (1=low 6=high) of Ethiopia in 2008 to that in 2012?
Your answer should be very brief. 1.01. What is the ratio of the Rating (1=low 6=high) in Senegal in 2008 to that in 2012?
Ensure brevity in your answer.  0.95. What is the ratio of the Rating (1=low 6=high) in Sub-Saharan Africa (developing only) in 2009 to that in 2010?
Your response must be concise. 1.01. What is the ratio of the Rating (1=low 6=high) of Congo (Republic) in 2009 to that in 2010?
Offer a terse response. 1. What is the ratio of the Rating (1=low 6=high) of Ethiopia in 2009 to that in 2010?
Keep it short and to the point. 1. What is the ratio of the Rating (1=low 6=high) in Senegal in 2009 to that in 2010?
Your answer should be compact. 1. What is the ratio of the Rating (1=low 6=high) of Sub-Saharan Africa (developing only) in 2009 to that in 2011?
Your response must be concise. 1.01. What is the ratio of the Rating (1=low 6=high) in Congo (Republic) in 2009 to that in 2012?
Make the answer very short. 1. What is the ratio of the Rating (1=low 6=high) of Senegal in 2009 to that in 2012?
Keep it short and to the point. 0.96. What is the ratio of the Rating (1=low 6=high) of Sub-Saharan Africa (developing only) in 2010 to that in 2011?
Your answer should be compact. 1. What is the ratio of the Rating (1=low 6=high) in Congo (Republic) in 2010 to that in 2011?
Provide a succinct answer. 1. What is the ratio of the Rating (1=low 6=high) in Sub-Saharan Africa (developing only) in 2010 to that in 2012?
Your response must be concise. 1.01. What is the ratio of the Rating (1=low 6=high) of Congo (Republic) in 2010 to that in 2012?
Your answer should be compact. 1. What is the ratio of the Rating (1=low 6=high) of Senegal in 2010 to that in 2012?
Offer a terse response. 0.96. What is the ratio of the Rating (1=low 6=high) of Sub-Saharan Africa (developing only) in 2011 to that in 2012?
Make the answer very short. 1.01. What is the ratio of the Rating (1=low 6=high) of Congo (Republic) in 2011 to that in 2012?
Provide a short and direct response. 1. What is the ratio of the Rating (1=low 6=high) of Ethiopia in 2011 to that in 2012?
Your answer should be very brief. 1. What is the difference between the highest and the second highest Rating (1=low 6=high) in Sub-Saharan Africa (developing only)?
Your response must be concise. 0.01. What is the difference between the highest and the lowest Rating (1=low 6=high) in Sub-Saharan Africa (developing only)?
Ensure brevity in your answer.  0.06. What is the difference between the highest and the lowest Rating (1=low 6=high) in Ethiopia?
Offer a very short reply. 0.03. 